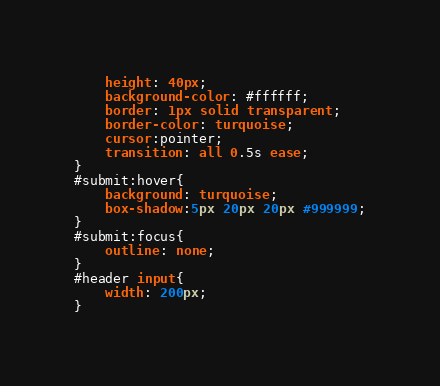Convert code to text. <code><loc_0><loc_0><loc_500><loc_500><_CSS_>    height: 40px;
    background-color: #ffffff;
    border: 1px solid transparent;
    border-color: turquoise;
    cursor:pointer;
    transition: all 0.5s ease;
}
#submit:hover{
    background: turquoise;
    box-shadow:5px 20px 20px #999999;
}
#submit:focus{
    outline: none;
}
#header input{
    width: 200px;
}</code> 